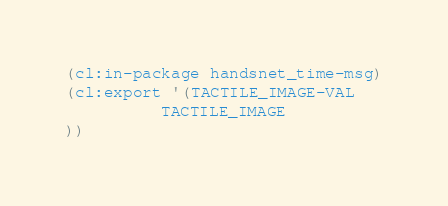<code> <loc_0><loc_0><loc_500><loc_500><_Lisp_>(cl:in-package handsnet_time-msg)
(cl:export '(TACTILE_IMAGE-VAL
          TACTILE_IMAGE
))</code> 